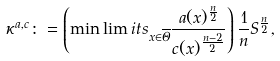Convert formula to latex. <formula><loc_0><loc_0><loc_500><loc_500>\kappa ^ { a , c } \colon = \left ( \min \lim i t s _ { x \in \overline { \Theta } } \frac { a ( x ) ^ { \frac { n } { 2 } } } { c ( x ) ^ { \frac { n - 2 } { 2 } } } \right ) \frac { 1 } { n } S ^ { \frac { n } { 2 } } ,</formula> 